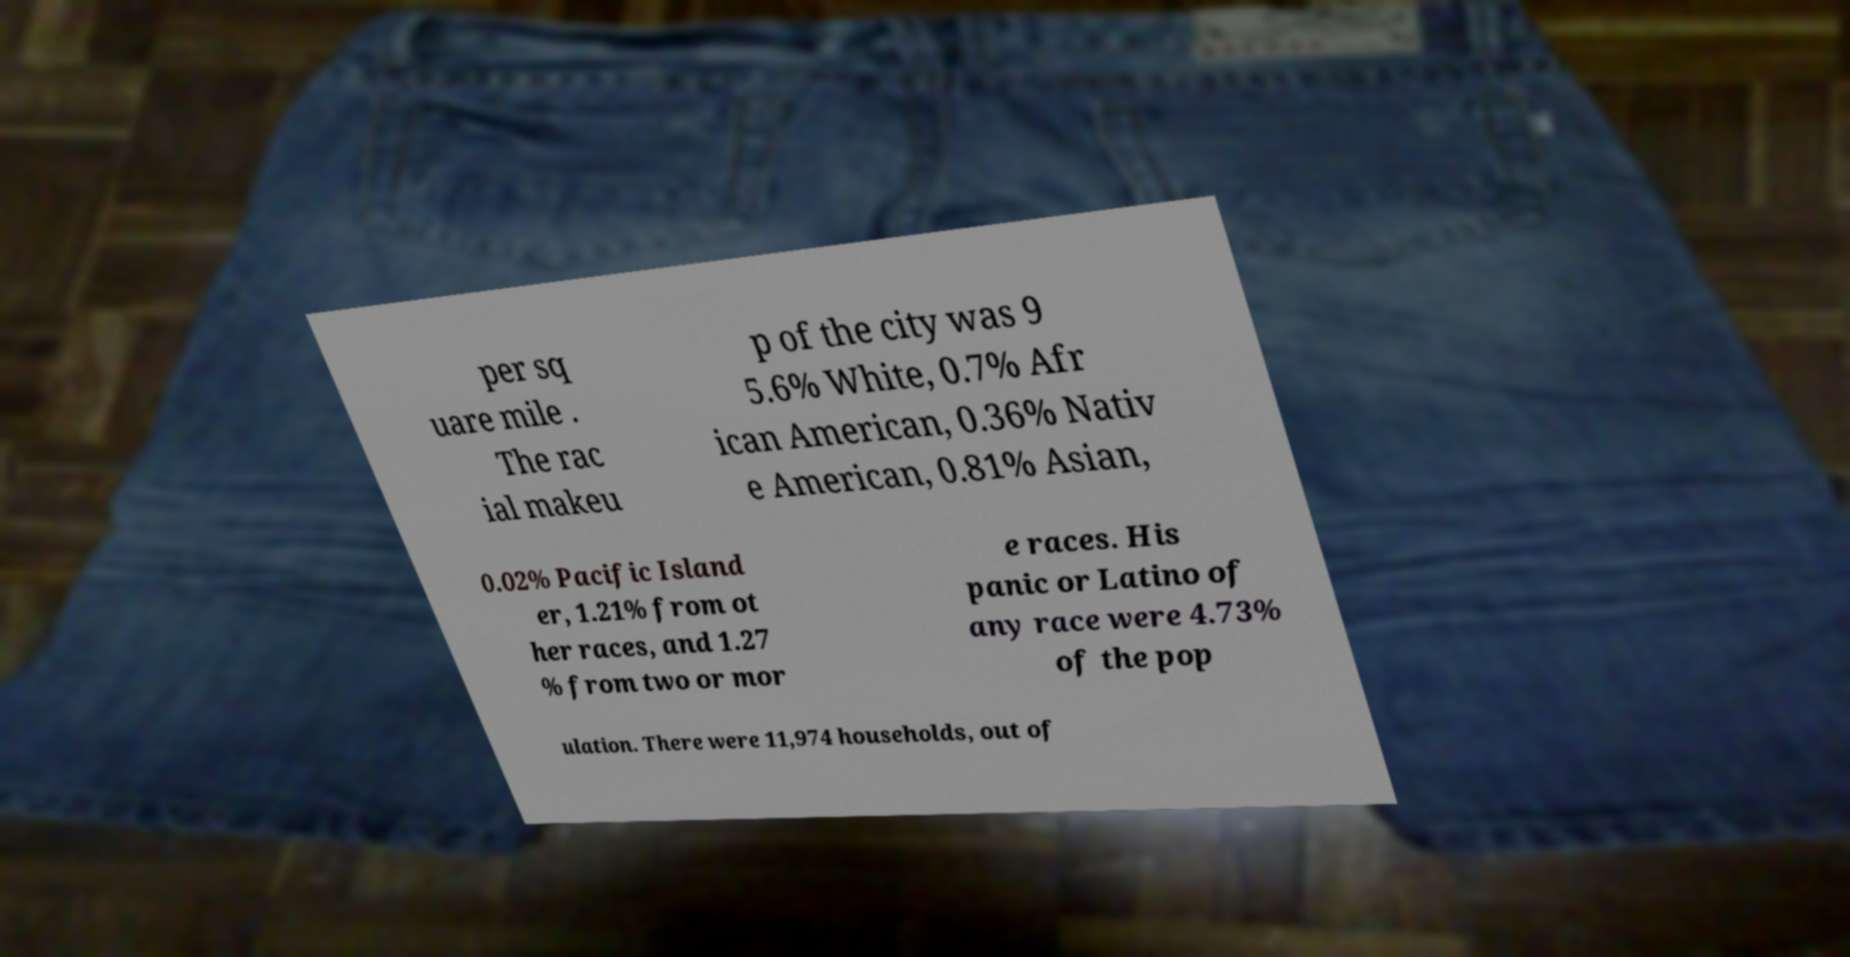Could you assist in decoding the text presented in this image and type it out clearly? per sq uare mile . The rac ial makeu p of the city was 9 5.6% White, 0.7% Afr ican American, 0.36% Nativ e American, 0.81% Asian, 0.02% Pacific Island er, 1.21% from ot her races, and 1.27 % from two or mor e races. His panic or Latino of any race were 4.73% of the pop ulation. There were 11,974 households, out of 